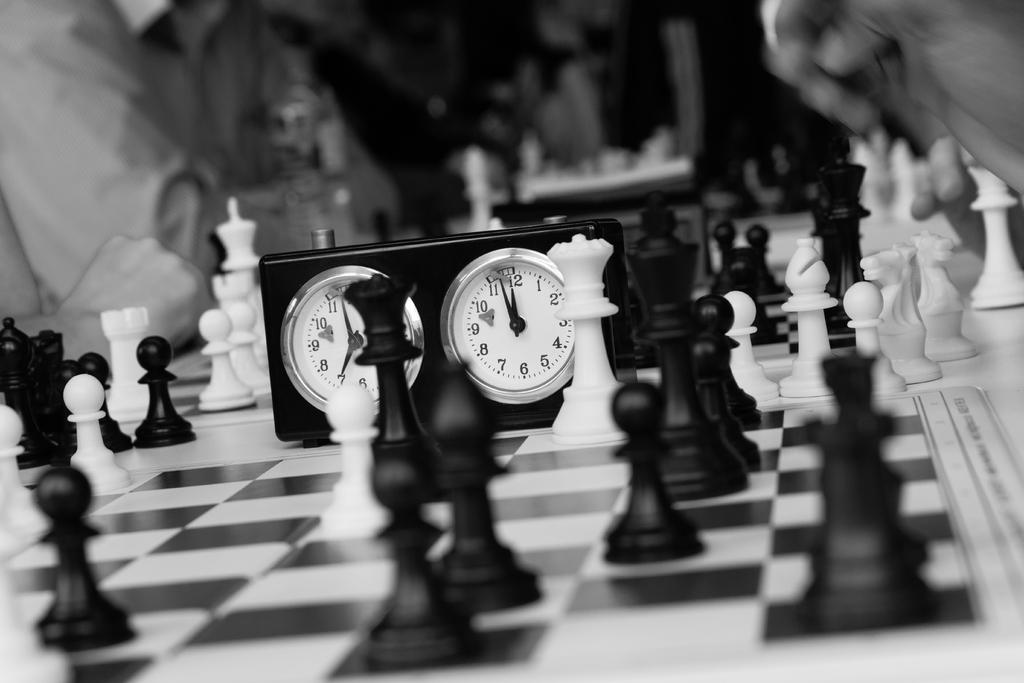What game is being played in the image? The game being played in the image is chess, as indicated by the presence of a chess board and chess coins. What is used to keep track of time during the game? There is a timer in the image, which is likely used to keep track of time during the game. What is the color scheme of the image? The image is in black and white color. How many balls are visible on the chess board in the image? There are no balls visible on the chess board in the image; the game being played is chess, which uses chess coins instead of balls. 